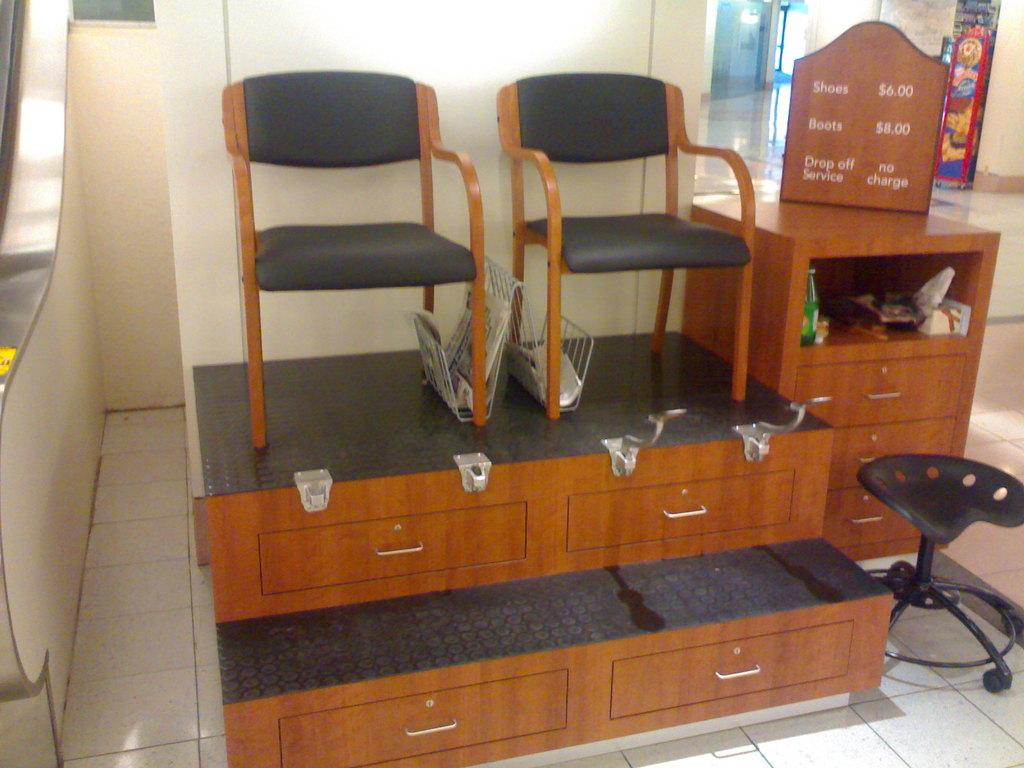How many chairs are on the desk in the image? There are two chairs on a desk in the image. Can you describe the position of the other chair in the image? There is another chair at the right side of the image. How many oranges are on the desk in the image? There are no oranges present on the desk in the image. What type of impulse can be seen affecting the chairs in the image? There is no impulse affecting the chairs in the image; they are stationary. Is there a church visible in the image? There is no church present in the image. 